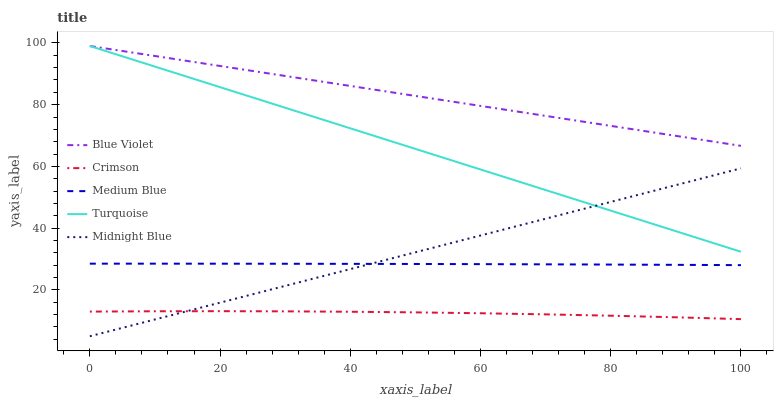Does Crimson have the minimum area under the curve?
Answer yes or no. Yes. Does Blue Violet have the maximum area under the curve?
Answer yes or no. Yes. Does Turquoise have the minimum area under the curve?
Answer yes or no. No. Does Turquoise have the maximum area under the curve?
Answer yes or no. No. Is Midnight Blue the smoothest?
Answer yes or no. Yes. Is Crimson the roughest?
Answer yes or no. Yes. Is Turquoise the smoothest?
Answer yes or no. No. Is Turquoise the roughest?
Answer yes or no. No. Does Midnight Blue have the lowest value?
Answer yes or no. Yes. Does Turquoise have the lowest value?
Answer yes or no. No. Does Blue Violet have the highest value?
Answer yes or no. Yes. Does Medium Blue have the highest value?
Answer yes or no. No. Is Medium Blue less than Turquoise?
Answer yes or no. Yes. Is Medium Blue greater than Crimson?
Answer yes or no. Yes. Does Crimson intersect Midnight Blue?
Answer yes or no. Yes. Is Crimson less than Midnight Blue?
Answer yes or no. No. Is Crimson greater than Midnight Blue?
Answer yes or no. No. Does Medium Blue intersect Turquoise?
Answer yes or no. No. 